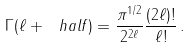Convert formula to latex. <formula><loc_0><loc_0><loc_500><loc_500>\Gamma ( \ell + \ h a l f ) = \frac { \pi ^ { 1 / 2 } } { 2 ^ { 2 \ell } } \frac { ( 2 \ell ) ! } { \ell ! } \, .</formula> 